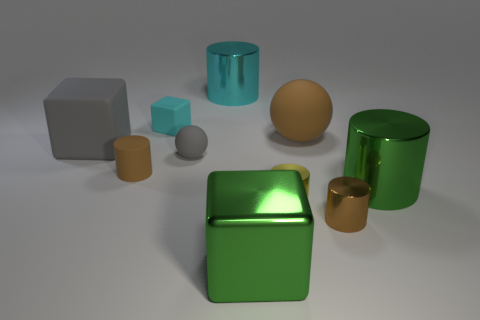The tiny matte thing that is the same color as the large matte ball is what shape?
Keep it short and to the point. Cylinder. How many blocks are small gray matte objects or tiny yellow metallic objects?
Your answer should be compact. 0. What color is the matte ball that is to the left of the yellow cylinder in front of the big cyan metallic object?
Offer a terse response. Gray. There is a small matte cube; does it have the same color as the matte ball that is to the right of the big cyan object?
Ensure brevity in your answer.  No. What size is the cyan cylinder that is the same material as the small yellow cylinder?
Make the answer very short. Large. What size is the metallic thing that is the same color as the large ball?
Your answer should be compact. Small. Is the big ball the same color as the small sphere?
Provide a short and direct response. No. There is a matte sphere that is left of the tiny shiny cylinder that is to the left of the big brown rubber object; are there any cubes that are in front of it?
Make the answer very short. Yes. What number of green metal blocks are the same size as the brown shiny thing?
Your response must be concise. 0. Does the matte block in front of the large brown object have the same size as the gray rubber thing that is right of the big gray matte block?
Keep it short and to the point. No. 